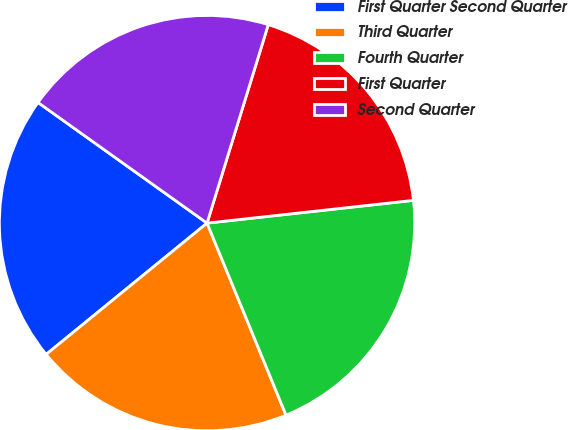<chart> <loc_0><loc_0><loc_500><loc_500><pie_chart><fcel>First Quarter Second Quarter<fcel>Third Quarter<fcel>Fourth Quarter<fcel>First Quarter<fcel>Second Quarter<nl><fcel>20.76%<fcel>20.32%<fcel>20.54%<fcel>18.49%<fcel>19.9%<nl></chart> 